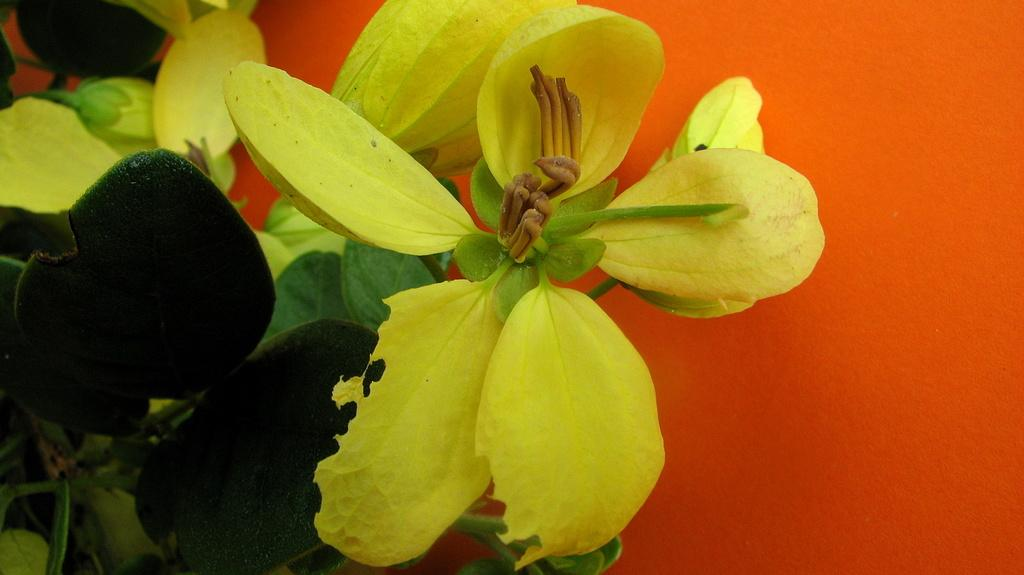What type of plants can be seen in the image? There are flowers in the image. What color are the flowers? The flowers are yellow. What other plant elements are visible in the image? There are leaves in the image. What color are the leaves? The leaves are green. What color is the background of the image? The background of the image is orange. What time of day is it in the image, and who is the achiever? The time of day is not mentioned in the image, and there is no reference to an achiever. The image only features flowers, leaves, and an orange background. 